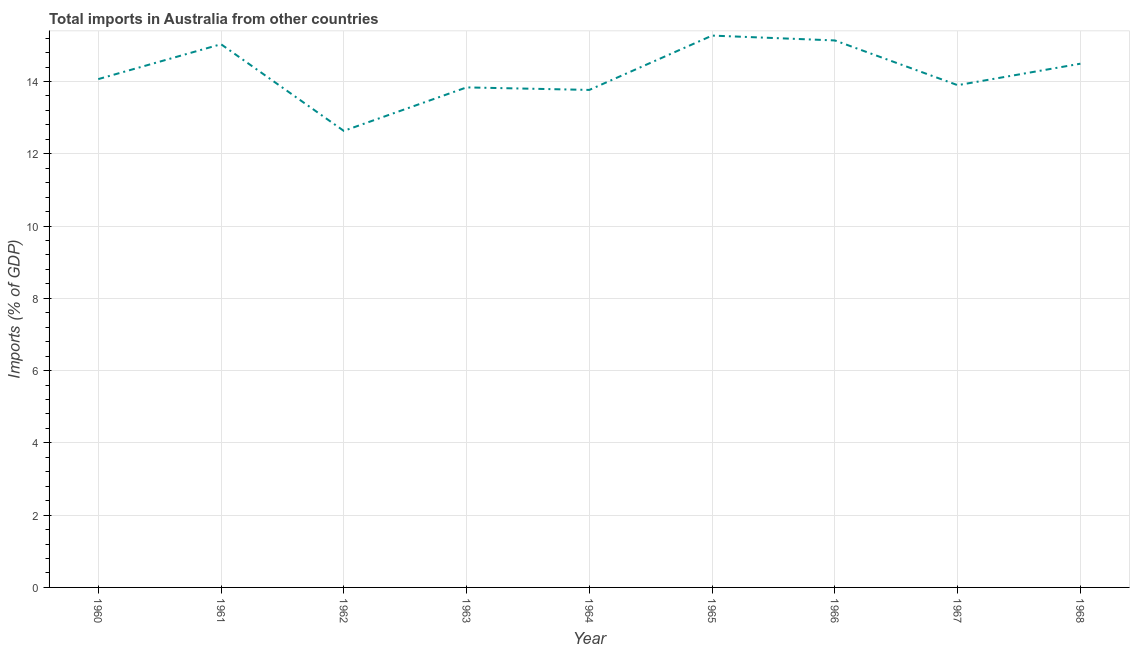What is the total imports in 1962?
Make the answer very short. 12.63. Across all years, what is the maximum total imports?
Make the answer very short. 15.27. Across all years, what is the minimum total imports?
Your response must be concise. 12.63. In which year was the total imports maximum?
Your response must be concise. 1965. In which year was the total imports minimum?
Make the answer very short. 1962. What is the sum of the total imports?
Give a very brief answer. 128.13. What is the difference between the total imports in 1961 and 1963?
Keep it short and to the point. 1.19. What is the average total imports per year?
Make the answer very short. 14.24. What is the median total imports?
Ensure brevity in your answer.  14.07. Do a majority of the years between 1964 and 1962 (inclusive) have total imports greater than 14 %?
Give a very brief answer. No. What is the ratio of the total imports in 1961 to that in 1962?
Your answer should be very brief. 1.19. Is the total imports in 1962 less than that in 1967?
Provide a short and direct response. Yes. Is the difference between the total imports in 1966 and 1968 greater than the difference between any two years?
Make the answer very short. No. What is the difference between the highest and the second highest total imports?
Provide a succinct answer. 0.13. What is the difference between the highest and the lowest total imports?
Offer a terse response. 2.64. How many lines are there?
Make the answer very short. 1. Are the values on the major ticks of Y-axis written in scientific E-notation?
Ensure brevity in your answer.  No. What is the title of the graph?
Offer a very short reply. Total imports in Australia from other countries. What is the label or title of the X-axis?
Provide a succinct answer. Year. What is the label or title of the Y-axis?
Keep it short and to the point. Imports (% of GDP). What is the Imports (% of GDP) of 1960?
Your answer should be very brief. 14.07. What is the Imports (% of GDP) in 1961?
Keep it short and to the point. 15.03. What is the Imports (% of GDP) of 1962?
Provide a short and direct response. 12.63. What is the Imports (% of GDP) in 1963?
Your answer should be compact. 13.84. What is the Imports (% of GDP) of 1964?
Provide a short and direct response. 13.77. What is the Imports (% of GDP) of 1965?
Offer a very short reply. 15.27. What is the Imports (% of GDP) of 1966?
Offer a terse response. 15.14. What is the Imports (% of GDP) of 1967?
Offer a very short reply. 13.9. What is the Imports (% of GDP) of 1968?
Provide a short and direct response. 14.49. What is the difference between the Imports (% of GDP) in 1960 and 1961?
Offer a very short reply. -0.97. What is the difference between the Imports (% of GDP) in 1960 and 1962?
Provide a short and direct response. 1.43. What is the difference between the Imports (% of GDP) in 1960 and 1963?
Give a very brief answer. 0.23. What is the difference between the Imports (% of GDP) in 1960 and 1964?
Keep it short and to the point. 0.3. What is the difference between the Imports (% of GDP) in 1960 and 1965?
Ensure brevity in your answer.  -1.2. What is the difference between the Imports (% of GDP) in 1960 and 1966?
Provide a succinct answer. -1.07. What is the difference between the Imports (% of GDP) in 1960 and 1967?
Keep it short and to the point. 0.17. What is the difference between the Imports (% of GDP) in 1960 and 1968?
Provide a succinct answer. -0.43. What is the difference between the Imports (% of GDP) in 1961 and 1962?
Offer a terse response. 2.4. What is the difference between the Imports (% of GDP) in 1961 and 1963?
Your answer should be very brief. 1.2. What is the difference between the Imports (% of GDP) in 1961 and 1964?
Keep it short and to the point. 1.26. What is the difference between the Imports (% of GDP) in 1961 and 1965?
Offer a terse response. -0.24. What is the difference between the Imports (% of GDP) in 1961 and 1966?
Keep it short and to the point. -0.1. What is the difference between the Imports (% of GDP) in 1961 and 1967?
Provide a succinct answer. 1.13. What is the difference between the Imports (% of GDP) in 1961 and 1968?
Your answer should be compact. 0.54. What is the difference between the Imports (% of GDP) in 1962 and 1963?
Your response must be concise. -1.2. What is the difference between the Imports (% of GDP) in 1962 and 1964?
Keep it short and to the point. -1.13. What is the difference between the Imports (% of GDP) in 1962 and 1965?
Your response must be concise. -2.64. What is the difference between the Imports (% of GDP) in 1962 and 1966?
Provide a succinct answer. -2.5. What is the difference between the Imports (% of GDP) in 1962 and 1967?
Give a very brief answer. -1.26. What is the difference between the Imports (% of GDP) in 1962 and 1968?
Keep it short and to the point. -1.86. What is the difference between the Imports (% of GDP) in 1963 and 1964?
Give a very brief answer. 0.07. What is the difference between the Imports (% of GDP) in 1963 and 1965?
Your answer should be compact. -1.43. What is the difference between the Imports (% of GDP) in 1963 and 1966?
Offer a very short reply. -1.3. What is the difference between the Imports (% of GDP) in 1963 and 1967?
Keep it short and to the point. -0.06. What is the difference between the Imports (% of GDP) in 1963 and 1968?
Provide a short and direct response. -0.66. What is the difference between the Imports (% of GDP) in 1964 and 1965?
Your answer should be compact. -1.5. What is the difference between the Imports (% of GDP) in 1964 and 1966?
Your answer should be very brief. -1.37. What is the difference between the Imports (% of GDP) in 1964 and 1967?
Offer a terse response. -0.13. What is the difference between the Imports (% of GDP) in 1964 and 1968?
Your response must be concise. -0.73. What is the difference between the Imports (% of GDP) in 1965 and 1966?
Offer a very short reply. 0.13. What is the difference between the Imports (% of GDP) in 1965 and 1967?
Provide a succinct answer. 1.37. What is the difference between the Imports (% of GDP) in 1965 and 1968?
Provide a succinct answer. 0.78. What is the difference between the Imports (% of GDP) in 1966 and 1967?
Make the answer very short. 1.24. What is the difference between the Imports (% of GDP) in 1966 and 1968?
Provide a short and direct response. 0.64. What is the difference between the Imports (% of GDP) in 1967 and 1968?
Make the answer very short. -0.59. What is the ratio of the Imports (% of GDP) in 1960 to that in 1961?
Offer a terse response. 0.94. What is the ratio of the Imports (% of GDP) in 1960 to that in 1962?
Keep it short and to the point. 1.11. What is the ratio of the Imports (% of GDP) in 1960 to that in 1965?
Your answer should be very brief. 0.92. What is the ratio of the Imports (% of GDP) in 1960 to that in 1966?
Your response must be concise. 0.93. What is the ratio of the Imports (% of GDP) in 1960 to that in 1968?
Keep it short and to the point. 0.97. What is the ratio of the Imports (% of GDP) in 1961 to that in 1962?
Keep it short and to the point. 1.19. What is the ratio of the Imports (% of GDP) in 1961 to that in 1963?
Your response must be concise. 1.09. What is the ratio of the Imports (% of GDP) in 1961 to that in 1964?
Provide a succinct answer. 1.09. What is the ratio of the Imports (% of GDP) in 1961 to that in 1965?
Keep it short and to the point. 0.98. What is the ratio of the Imports (% of GDP) in 1961 to that in 1967?
Offer a very short reply. 1.08. What is the ratio of the Imports (% of GDP) in 1962 to that in 1964?
Offer a very short reply. 0.92. What is the ratio of the Imports (% of GDP) in 1962 to that in 1965?
Provide a succinct answer. 0.83. What is the ratio of the Imports (% of GDP) in 1962 to that in 1966?
Provide a short and direct response. 0.83. What is the ratio of the Imports (% of GDP) in 1962 to that in 1967?
Offer a very short reply. 0.91. What is the ratio of the Imports (% of GDP) in 1962 to that in 1968?
Keep it short and to the point. 0.87. What is the ratio of the Imports (% of GDP) in 1963 to that in 1964?
Offer a terse response. 1. What is the ratio of the Imports (% of GDP) in 1963 to that in 1965?
Make the answer very short. 0.91. What is the ratio of the Imports (% of GDP) in 1963 to that in 1966?
Your response must be concise. 0.91. What is the ratio of the Imports (% of GDP) in 1963 to that in 1967?
Offer a very short reply. 1. What is the ratio of the Imports (% of GDP) in 1963 to that in 1968?
Make the answer very short. 0.95. What is the ratio of the Imports (% of GDP) in 1964 to that in 1965?
Provide a short and direct response. 0.9. What is the ratio of the Imports (% of GDP) in 1964 to that in 1966?
Make the answer very short. 0.91. What is the ratio of the Imports (% of GDP) in 1965 to that in 1966?
Give a very brief answer. 1.01. What is the ratio of the Imports (% of GDP) in 1965 to that in 1967?
Ensure brevity in your answer.  1.1. What is the ratio of the Imports (% of GDP) in 1965 to that in 1968?
Offer a terse response. 1.05. What is the ratio of the Imports (% of GDP) in 1966 to that in 1967?
Your answer should be very brief. 1.09. What is the ratio of the Imports (% of GDP) in 1966 to that in 1968?
Provide a succinct answer. 1.04. 